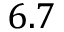<formula> <loc_0><loc_0><loc_500><loc_500>6 . 7</formula> 